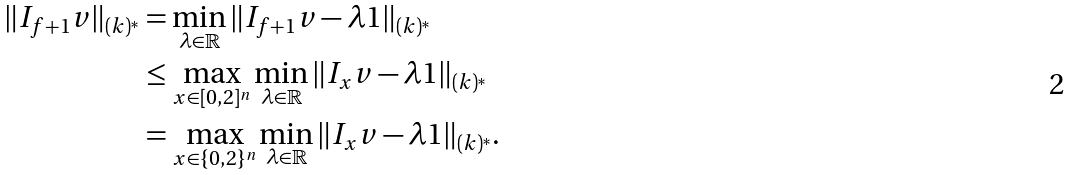Convert formula to latex. <formula><loc_0><loc_0><loc_500><loc_500>\| I _ { f + { 1 } } v \| _ { ( k ) ^ { * } } & = \min _ { \lambda \in \mathbb { R } } \| I _ { f + { 1 } } v - \lambda { 1 } \| _ { ( k ) ^ { * } } \\ & \leq \max _ { x \in [ 0 , 2 ] ^ { n } } \min _ { \lambda \in \mathbb { R } } \| I _ { x } v - \lambda { 1 } \| _ { ( k ) ^ { * } } \\ & = \max _ { x \in \{ 0 , 2 \} ^ { n } } \min _ { \lambda \in \mathbb { R } } \| I _ { x } v - \lambda { 1 } \| _ { ( k ) ^ { * } } .</formula> 